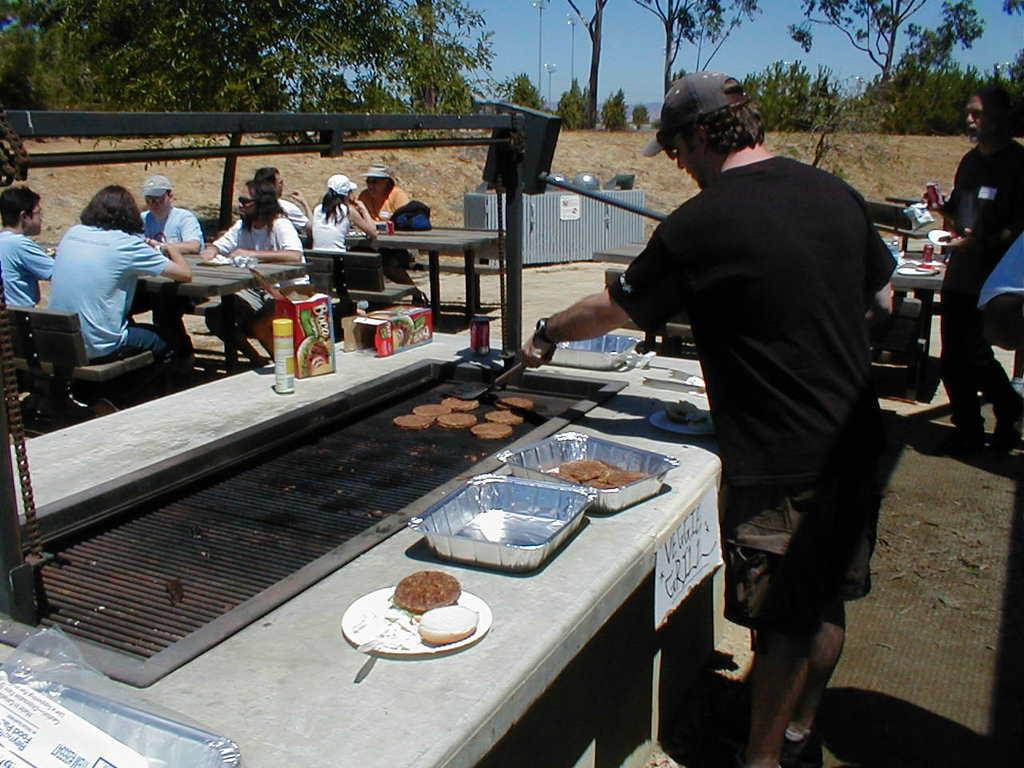Please provide a concise description of this image. In this image a person is standing on the land. He is wearing black top and cap. Before him there is a table having a grill, trays, plates, boxes, bottles are on it. On the grill there is some food. Left side there are few persons sitting on the chairs before the tables. Right side there is a person walking on the land. Top of the image there are few plants and trees on the land. Behind it there is sky. 